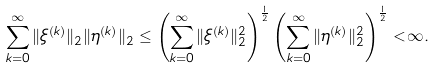<formula> <loc_0><loc_0><loc_500><loc_500>\sum _ { k = 0 } ^ { \infty } \| \xi ^ { ( k ) } \| _ { 2 } \| \eta ^ { ( k ) } \| _ { 2 } \leq \left ( \sum _ { k = 0 } ^ { \infty } \| \xi ^ { ( k ) } \| _ { 2 } ^ { 2 } \right ) ^ { \frac { 1 } { 2 } } \left ( \sum _ { k = 0 } ^ { \infty } \| \eta ^ { ( k ) } \| _ { 2 } ^ { 2 } \right ) ^ { \frac { 1 } { 2 } } < \infty .</formula> 